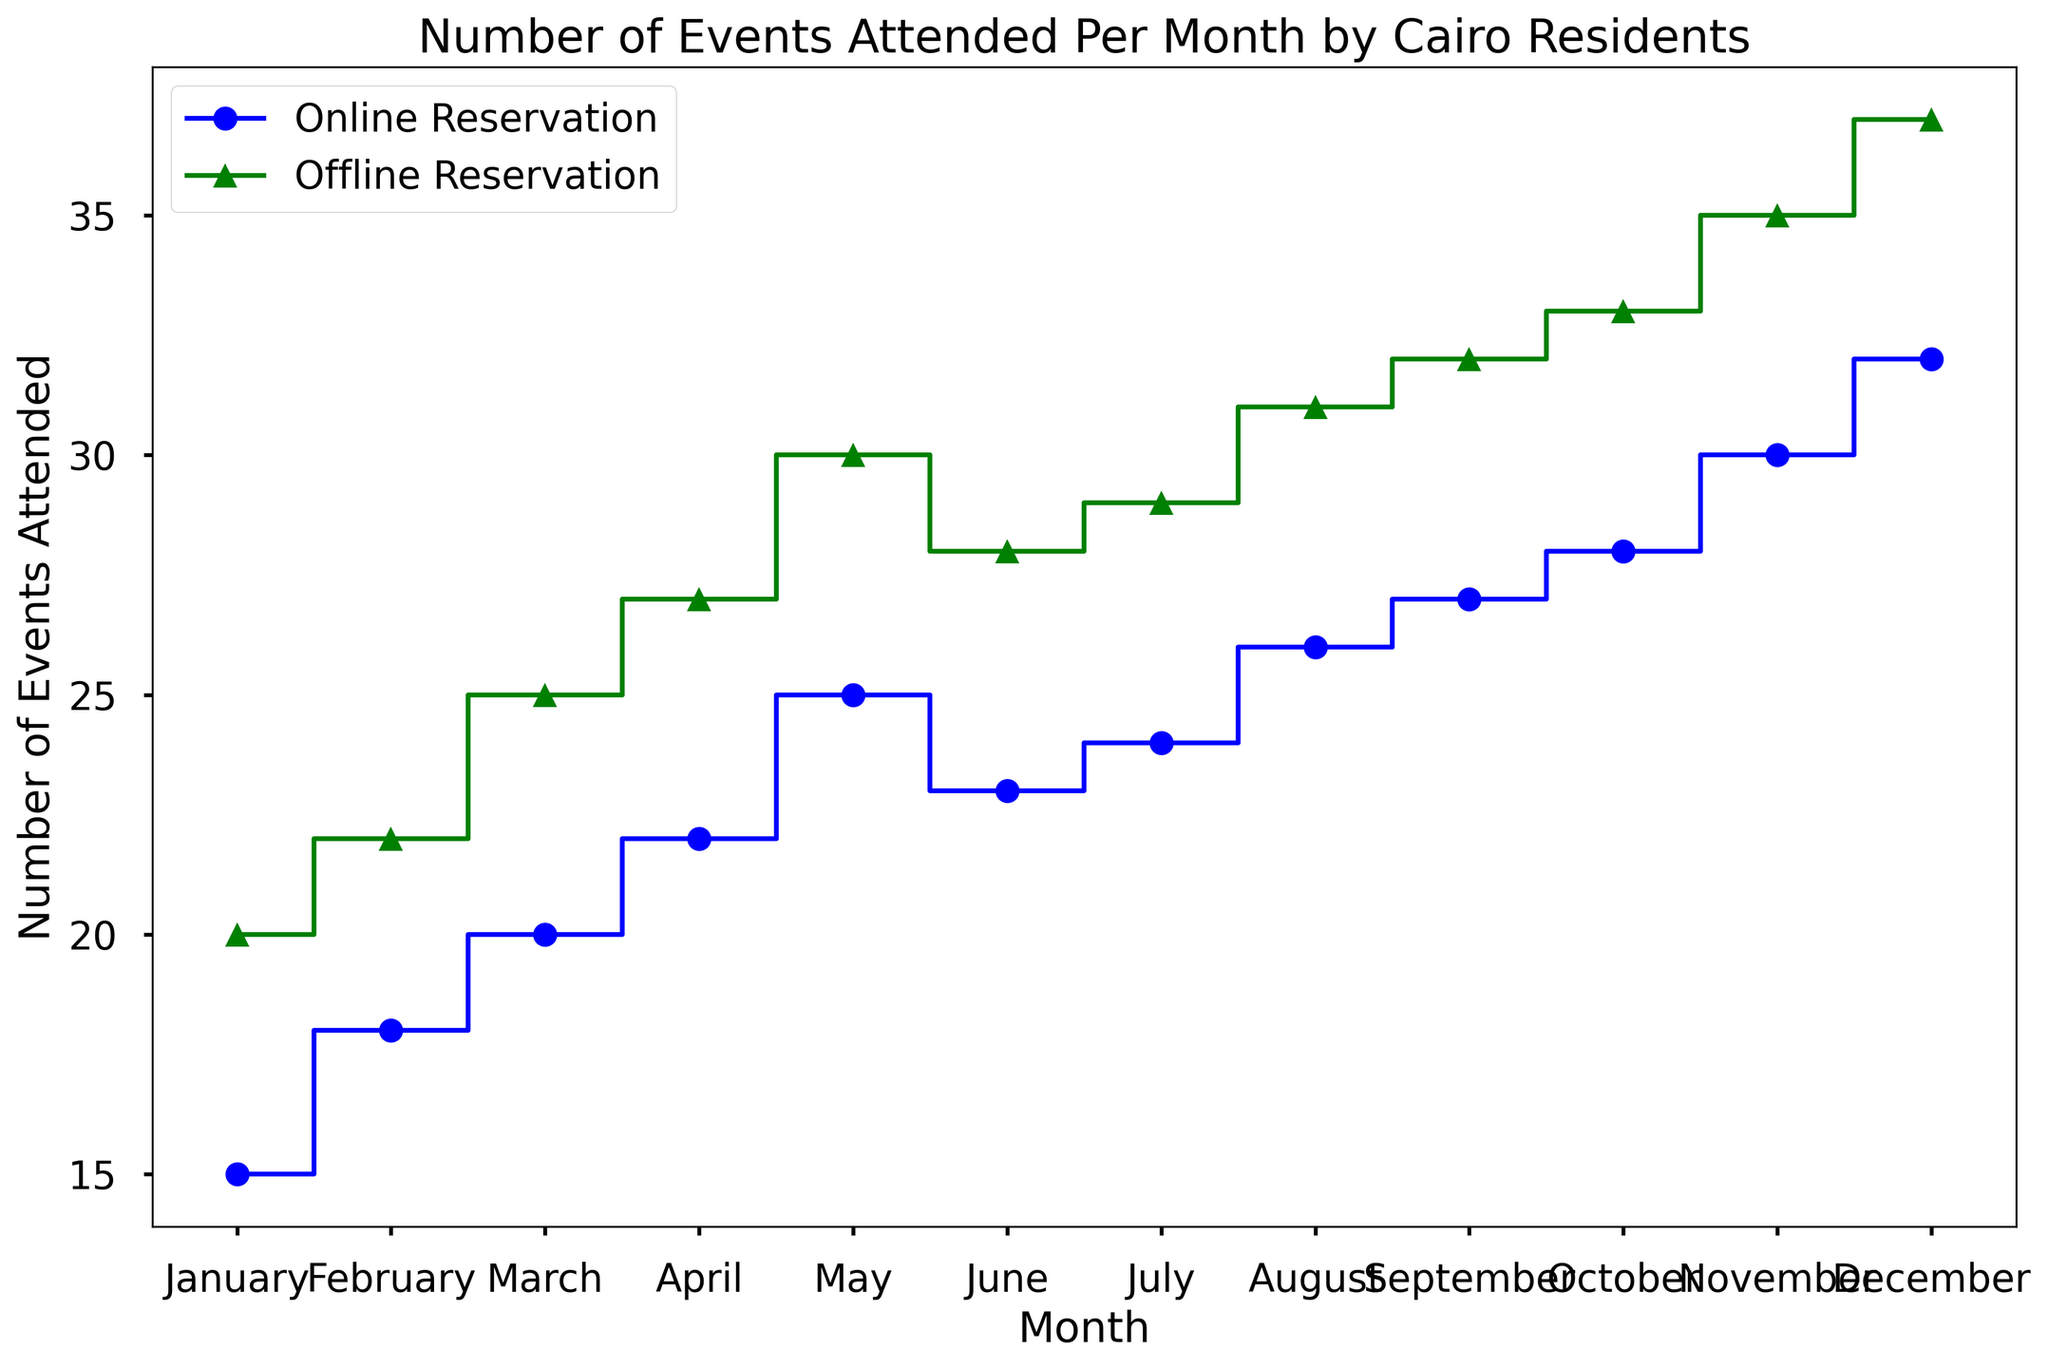Which month had the highest number of offline events? According to the plot, December had the highest point for offline events, indicating the maximum number of offline events attended.
Answer: December What is the trend in the number of online events attended from January to December? By observing the plot, we see that the number of online events increased gradually from January to December. The staircase-like steps in the plot rise steadily over the months.
Answer: Increasing In which month was the difference between online and offline events attended the smallest? By comparing the gaps between the two lines on the plot for each month, April seems to have the smallest difference between online (22) and offline (27) events. The difference is 5.
Answer: April In August, how many more offline events were attended compared to online events? In August, the number of offline events attended was 31, while the number of online events attended was 26. So, the difference is 31 - 26 = 5.
Answer: 5 Which mode of reservation saw more events attended consistently throughout the year? By comparing the two lines, it is apparent that the offline events line is consistently above the online events line throughout all the months.
Answer: Offline By how much did the number of online events increase from January to July? The number of online events in January was 15, and by July, it was 24. The increase is 24 - 15 = 9.
Answer: 9 In which months did both online and offline events see an increase compared to the previous month? By looking at the plot, both lines show an increase in February, March, April, May, August, September, October, November, and December compared to the preceding month.
Answer: February, March, April, May, August, September, October, November, December What's the average number of offline events attended from March to June? The number of offline events attended from March to June are 25, 27, 30, and 28. Summing these up gives 25 + 27 + 30 + 28 = 110. The average is 110 / 4 = 27.5.
Answer: 27.5 Which color represents the online reservation in the stairs plot? The plot uses blue for the online reservation as indicated by the labels and the color of the line with circles markers.
Answer: Blue 